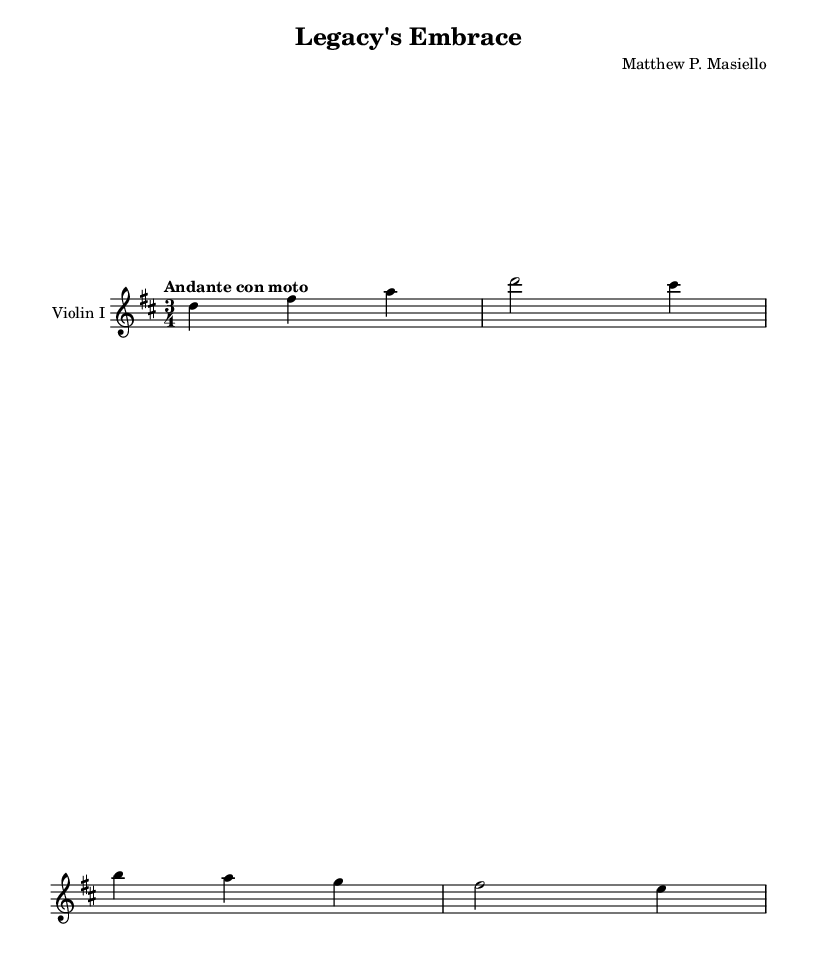What is the key signature of this music? The key signature is indicated by the number of sharps or flats at the beginning of the staff. In this sheet music, there are two sharps, which correspond to the D major scale.
Answer: D major What is the time signature of this music? The time signature is represented as a fraction at the beginning of the staff. Here, it shows 3/4, which means there are three beats in each measure and the quarter note gets one beat.
Answer: 3/4 What is the tempo marking of this piece? The tempo marking is found at the beginning, typically indicated in Italian. In this music sheet, it reads "Andante con moto," suggesting a moderately slow tempo with a sense of movement.
Answer: Andante con moto How many measures are present in the music? To find the number of measures, count how many sets of vertical bar lines are in the music. Each set indicates a measure. There are four measures in the provided music.
Answer: 4 What is the starting note of the first measure? The first measure contains a note indicated as D. Notes are read from bottom to top, and the first note in this measure is clearly labeled as D.
Answer: D What is the highest note played in the piece? To determine the highest note, examine all the notes within the music. The highest note is indicated as A, which is present in the first measure.
Answer: A What theme does the title "Legacy's Embrace" suggest about the symphony? The title suggests that the piece may explore themes of personal growth and the importance of legacy, reflecting on experiences that shape one's identity over time.
Answer: Personal growth 